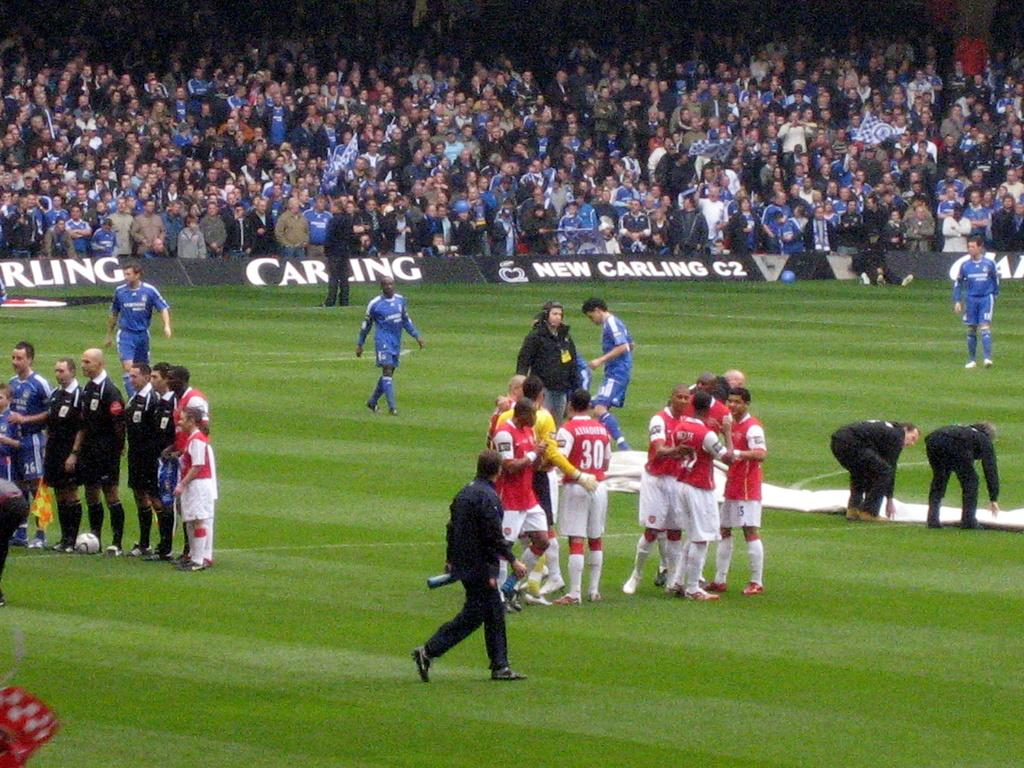What is the location of the persons in the image? The persons are on the ground in the image. What type of signage can be seen in the image? There are hoardings in the image. What can be seen in the background of the image? There is a crowd visible in the background of the image. Can you see any lakes or wooded areas in the image? No, there are no lakes or wooded areas visible in the image. Is there a lamp illuminating the persons in the image? No, there is no lamp present in the image. 